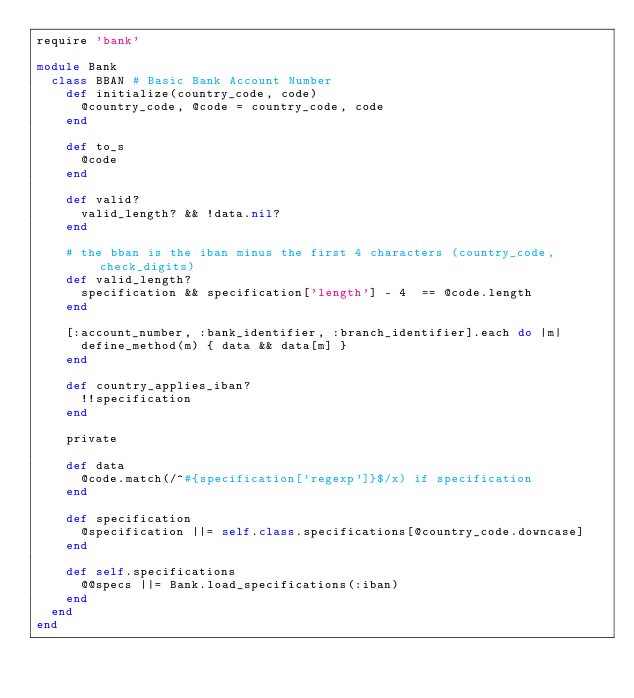Convert code to text. <code><loc_0><loc_0><loc_500><loc_500><_Ruby_>require 'bank'

module Bank
  class BBAN # Basic Bank Account Number
    def initialize(country_code, code)
      @country_code, @code = country_code, code
    end

    def to_s
      @code
    end

    def valid?
      valid_length? && !data.nil?
    end

    # the bban is the iban minus the first 4 characters (country_code, check_digits)
    def valid_length?
      specification && specification['length'] - 4  == @code.length
    end

    [:account_number, :bank_identifier, :branch_identifier].each do |m|
      define_method(m) { data && data[m] }
    end
    
    def country_applies_iban?
      !!specification
    end

    private

    def data
      @code.match(/^#{specification['regexp']}$/x) if specification
    end

    def specification
      @specification ||= self.class.specifications[@country_code.downcase]
    end

    def self.specifications
      @@specs ||= Bank.load_specifications(:iban)
    end
  end
end
</code> 